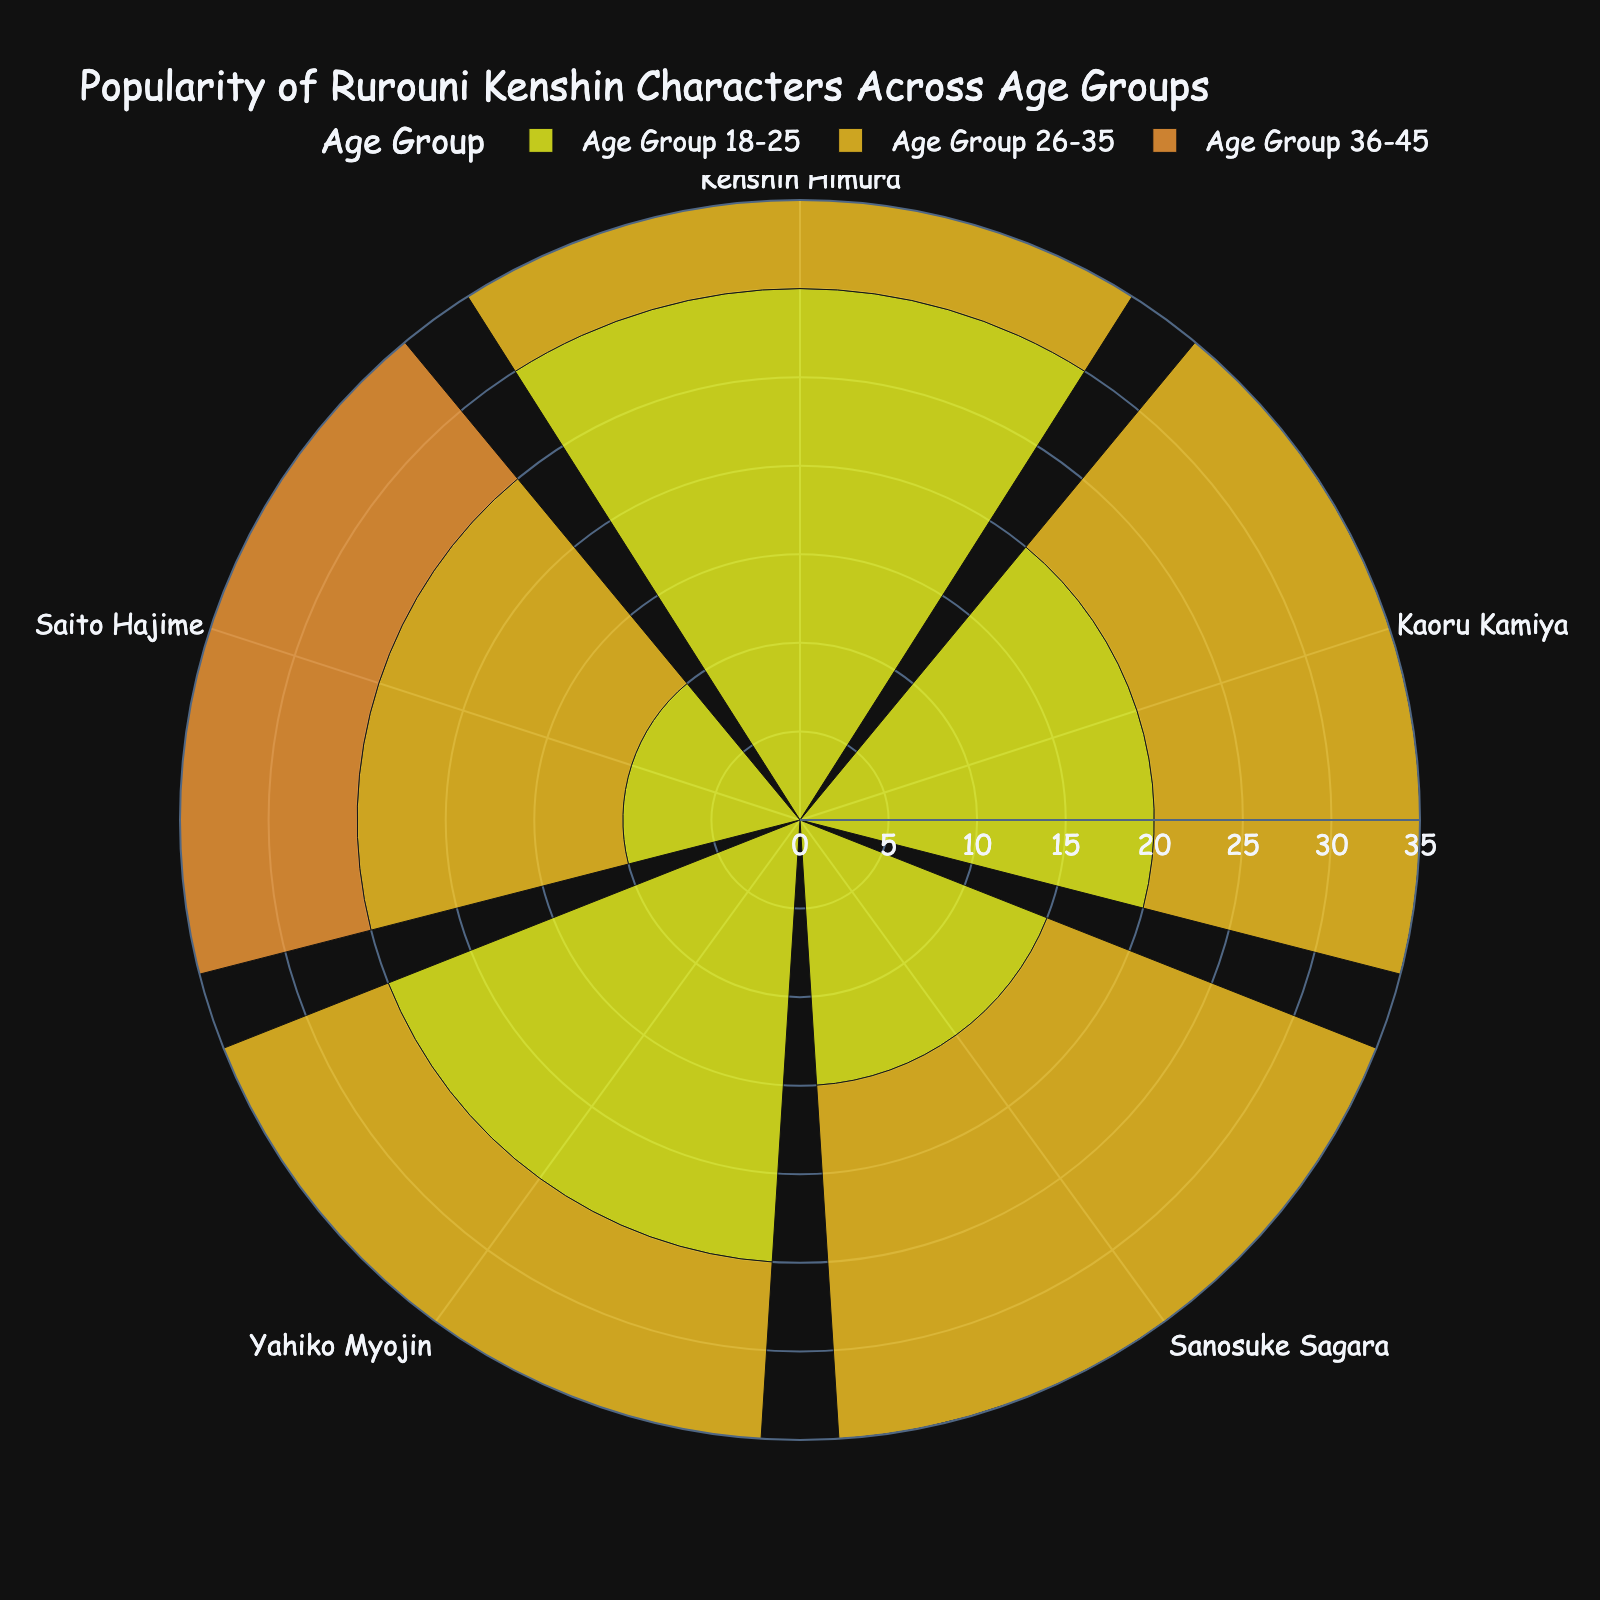What is the title of the figure? The title of the figure is displayed prominently at the top of the plot.
Answer: Popularity of Rurouni Kenshin Characters Across Age Groups Which age group shows the highest popularity for Kenshin Himura? Look at Kenshin Himura's section and observe the length of the bars for each age group. The longest bar indicates the highest popularity.
Answer: Age Group 18-25 What is the combined popularity of Kaoru Kamiya across all age groups? Sum the popularity values of Kaoru Kamiya for age groups 18-25, 26-35, and 36-45: 20 + 15 + 10.
Answer: 45 How does Sanosuke Sagara's popularity in the 36-45 age group compare to his popularity in the 18-25 age group? Look at the bars corresponding to Sanosuke Sagara for both the 36-45 and 18-25 age groups. The bar height indicates popularity.
Answer: Higher What is the difference in popularity between Yahiko Myojin and Saito Hajime among the 26-35 age group? Locate the bars for Yahiko Myojin and Saito Hajime in the 26-35 age group and subtract the smaller value from the larger value: 20 - 15.
Answer: 5 Which character has the least popularity across all age groups combined? Sum the popularity values for each character across all age groups and compare the totals to find the smallest: Kenshin Himura (70), Kaoru Kamiya (45), Sanosuke Sagara (60), Yahiko Myojin (55), Saito Hajime (45).
Answer: Kaoru and Saito What is the average popularity of all characters in the 18-25 age group? Sum the popularity values of the characters in the 18-25 age group and divide by the number of characters: (30 + 20 + 15 + 25 + 10) / 5.
Answer: 20 Which character has the most balanced popularity across age groups? Look for the character whose bar lengths are most similar across all age groups.
Answer: Sanosuke Sagara Is Kaoru Kamiya more popular among the younger (18-25) or older (36-45) age group? Compare the bar lengths for Kaoru Kamiya in the 18-25 and 36-45 age groups. Longer bar indicates higher popularity.
Answer: Younger (18-25) What is the total popularity of all characters in the 26-35 age group? Sum the popularity values for all characters in the 26-35 age group: 25 + 15 + 20 + 20 + 15.
Answer: 95 